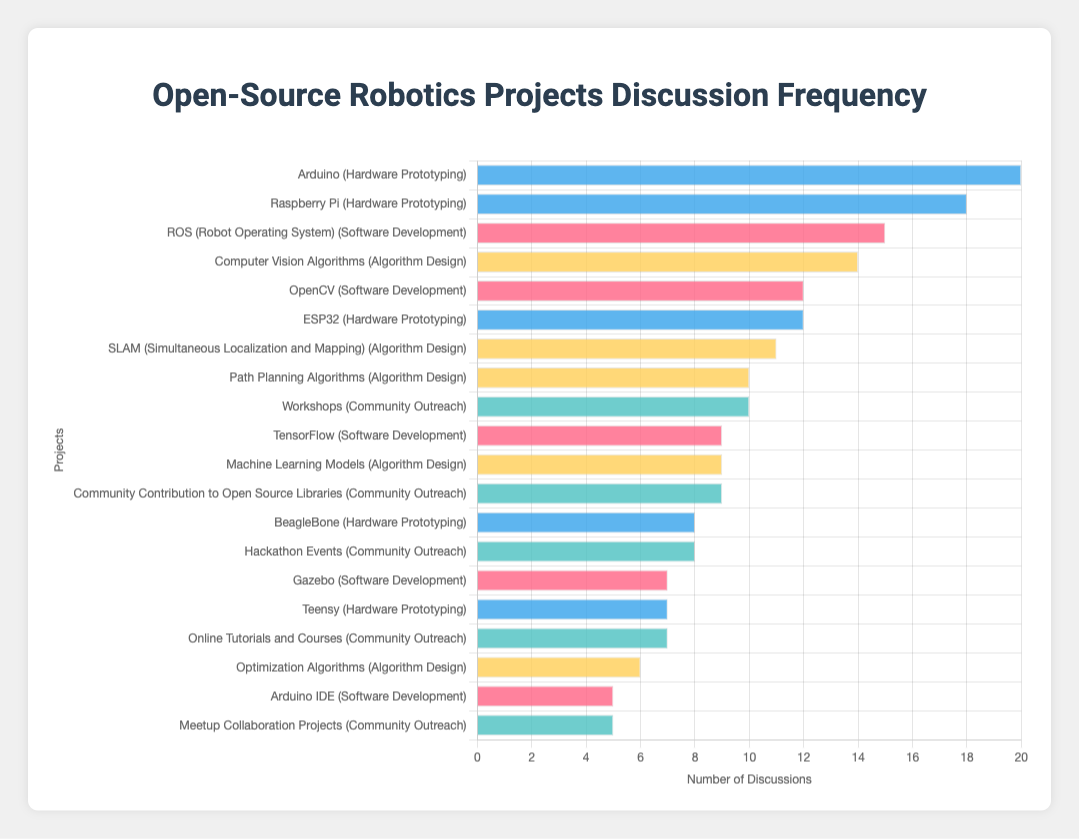Which project has the highest number of discussions? From the chart, we can see that "Arduino" under the "Hardware Prototyping" category has the longest bar, indicating it has the highest number of discussions.
Answer: Arduino How many more discussions does the top project have compared to the second top project? The top project, "Arduino," has 20 discussions, while the second top project, "Raspberry Pi," has 18 discussions. The difference is 20 - 18 = 2.
Answer: 2 Which category includes the project "TensorFlow"? The project "TensorFlow" is listed under the "Software Development" category, as shown in the combined labels on the y-axis of the chart.
Answer: Software Development What is the total number of discussions for projects in the "Algorithm Design" category? Sum the discussion numbers for all projects in "Algorithm Design": 10 (Path Planning) + 14 (Computer Vision) + 9 (Machine Learning) + 11 (SLAM) + 6 (Optimization) = 50.
Answer: 50 Are there more discussions about "ROS (Robot Operating System)" or "SLAM (Simultaneous Localization and Mapping)"? "ROS (Robot Operating System)" has 15 discussions, while "SLAM (Simultaneous Localization and Mapping)" has 11 discussions. So, "ROS" has more.
Answer: ROS (Robot Operating System) How many projects have discussions between 5 and 10 inclusive? Count the projects where the number of discussions is between 5 and 10: "Gazebo" (7), "Arduino IDE" (5), "BeagleBone" (8), "Teensy" (7), "Machine Learning Models" (9), "Optimization Algorithms" (6), "Hackathon Events" (8), "Meetup Collaboration Projects" (5), "Online Tutorials and Courses" (7). There are 9 such projects.
Answer: 9 Which category has the most projects with 10 or more discussions? Count the projects with 10 or more discussions in each category: "Software Development" (2), "Hardware Prototyping" (3), "Algorithm Design" (3), "Community Outreach" (1). The "Hardware Prototyping" and "Algorithm Design" categories each have 3 such projects.
Answer: Hardware Prototyping and Algorithm Design What is the average number of discussions for projects in the "Community Outreach" category? Calculate the sum of discussions for "Community Outreach": 8 (Hackathon Events) + 10 (Workshops) + 5 (Meetup Collaboration Projects) + 7 (Online Tutorials) + 9 (Community Contribution) = 39. Divide by the number of projects: 39 / 5 = 7.8.
Answer: 7.8 Which project within the "Software Development" category has received the least discussion? "Arduino IDE" in the "Software Development" category has received the least discussions at 5, as indicated by the shortest bar in this sub-category.
Answer: Arduino IDE 